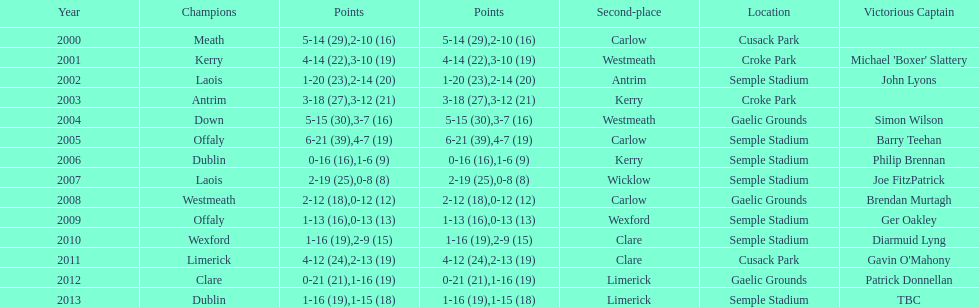How many winners won in semple stadium? 7. 